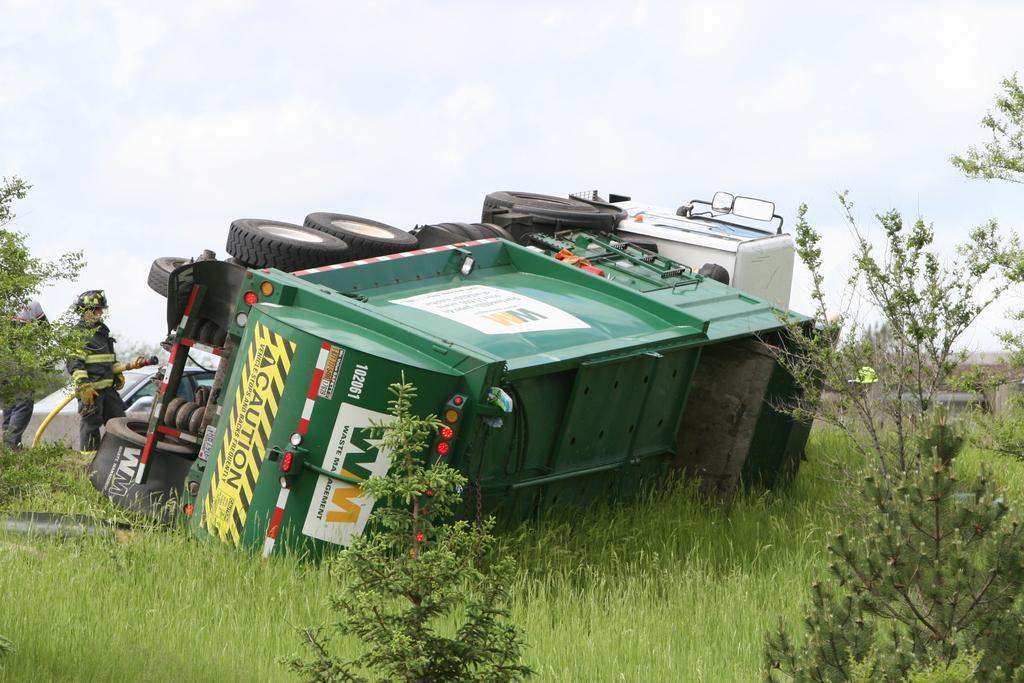Describe this image in one or two sentences. As we can see in the image there is a truck, plants, grass, a person standing over here and sky. 